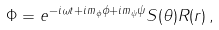<formula> <loc_0><loc_0><loc_500><loc_500>\Phi = e ^ { - i \omega t + i m _ { \phi } \phi + i m _ { \psi } \psi } S ( \theta ) R ( r ) \, ,</formula> 